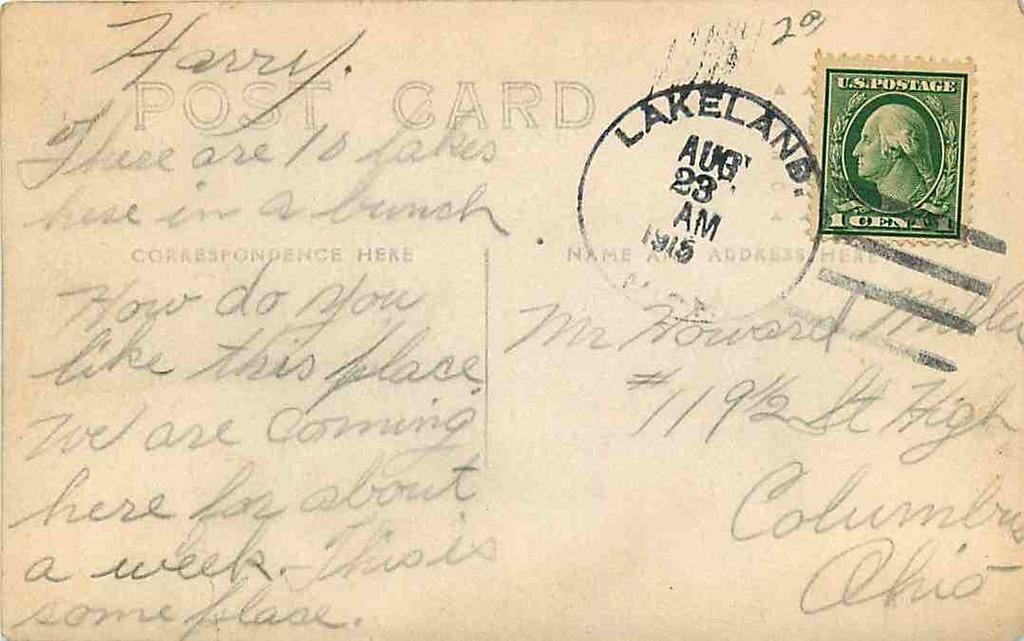How long ago was this written?
Offer a terse response. 1915. What city is the postmark from?
Your answer should be compact. Lakeland. 